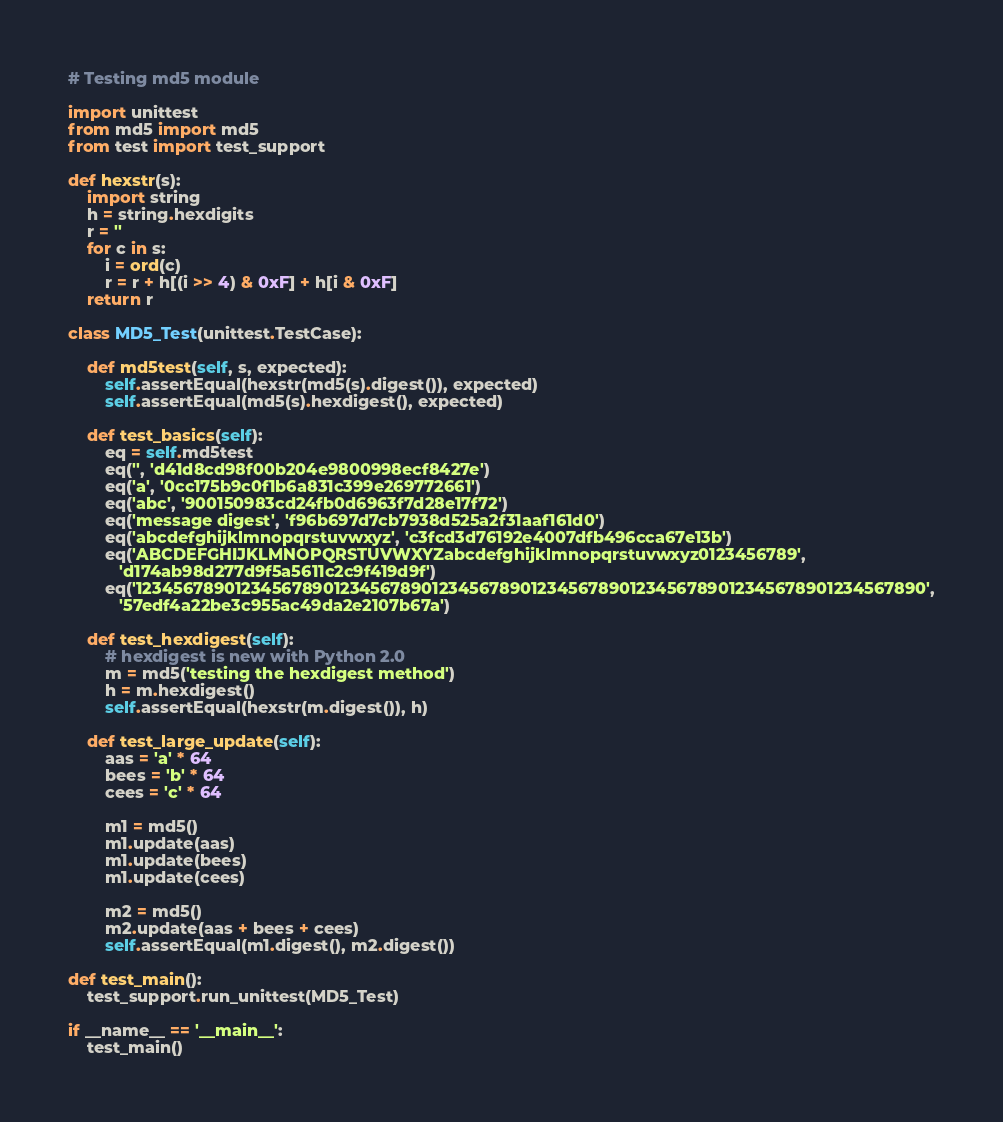Convert code to text. <code><loc_0><loc_0><loc_500><loc_500><_Python_># Testing md5 module

import unittest
from md5 import md5
from test import test_support

def hexstr(s):
    import string
    h = string.hexdigits
    r = ''
    for c in s:
        i = ord(c)
        r = r + h[(i >> 4) & 0xF] + h[i & 0xF]
    return r

class MD5_Test(unittest.TestCase):

    def md5test(self, s, expected):
        self.assertEqual(hexstr(md5(s).digest()), expected)
        self.assertEqual(md5(s).hexdigest(), expected)

    def test_basics(self):
        eq = self.md5test
        eq('', 'd41d8cd98f00b204e9800998ecf8427e')
        eq('a', '0cc175b9c0f1b6a831c399e269772661')
        eq('abc', '900150983cd24fb0d6963f7d28e17f72')
        eq('message digest', 'f96b697d7cb7938d525a2f31aaf161d0')
        eq('abcdefghijklmnopqrstuvwxyz', 'c3fcd3d76192e4007dfb496cca67e13b')
        eq('ABCDEFGHIJKLMNOPQRSTUVWXYZabcdefghijklmnopqrstuvwxyz0123456789',
           'd174ab98d277d9f5a5611c2c9f419d9f')
        eq('12345678901234567890123456789012345678901234567890123456789012345678901234567890',
           '57edf4a22be3c955ac49da2e2107b67a')

    def test_hexdigest(self):
        # hexdigest is new with Python 2.0
        m = md5('testing the hexdigest method')
        h = m.hexdigest()
        self.assertEqual(hexstr(m.digest()), h)

    def test_large_update(self):
        aas = 'a' * 64
        bees = 'b' * 64
        cees = 'c' * 64

        m1 = md5()
        m1.update(aas)
        m1.update(bees)
        m1.update(cees)

        m2 = md5()
        m2.update(aas + bees + cees)
        self.assertEqual(m1.digest(), m2.digest())

def test_main():
    test_support.run_unittest(MD5_Test)

if __name__ == '__main__':
    test_main()
</code> 